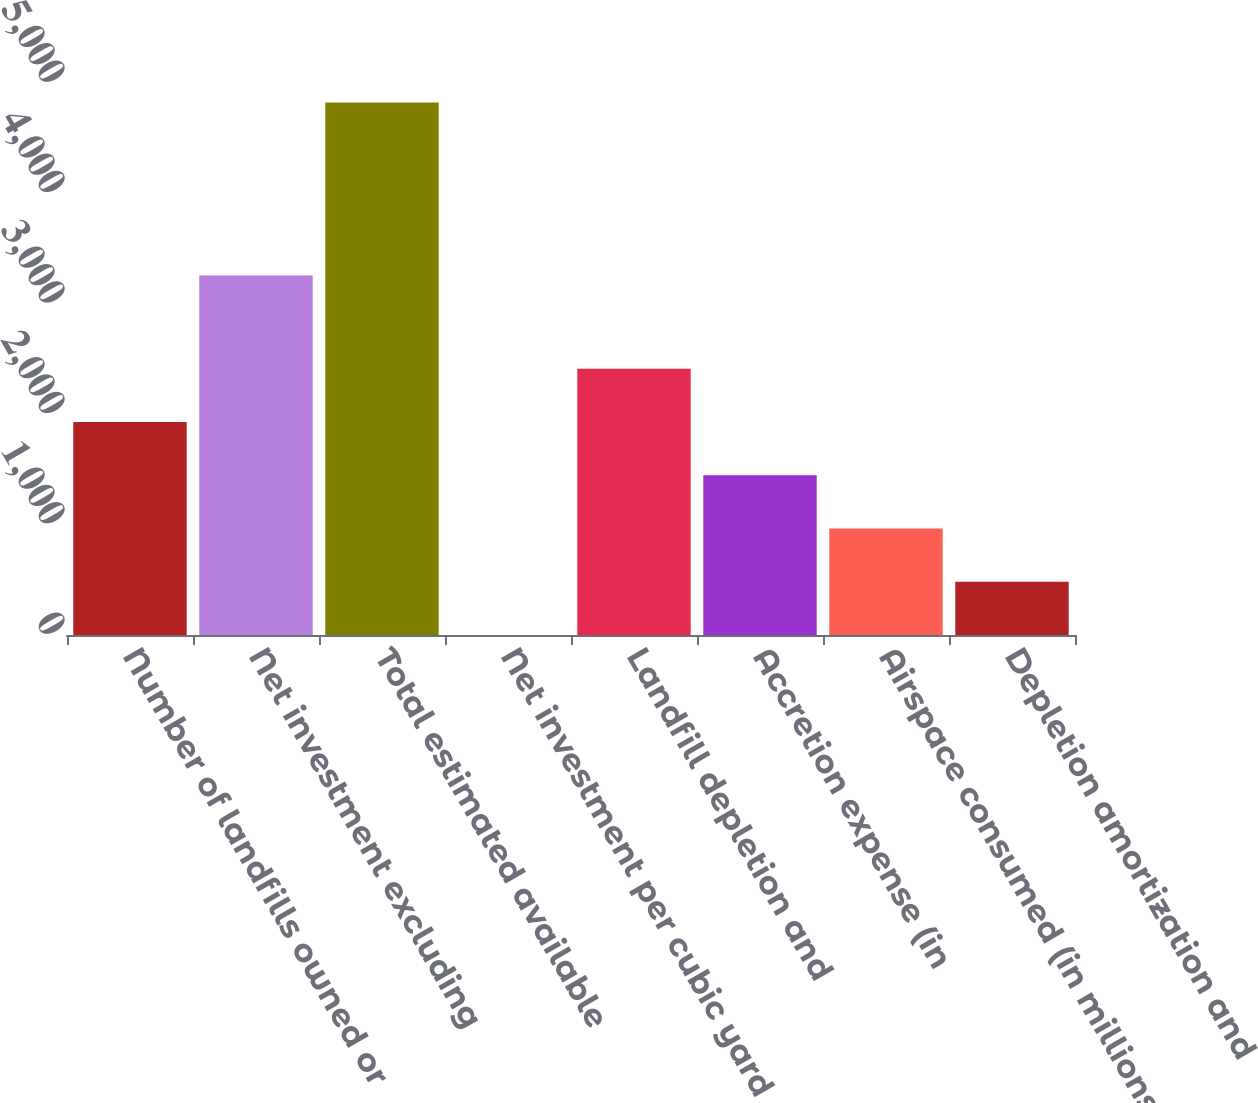Convert chart. <chart><loc_0><loc_0><loc_500><loc_500><bar_chart><fcel>Number of landfills owned or<fcel>Net investment excluding<fcel>Total estimated available<fcel>Net investment per cubic yard<fcel>Landfill depletion and<fcel>Accretion expense (in<fcel>Airspace consumed (in millions<fcel>Depletion amortization and<nl><fcel>1929.56<fcel>3256.1<fcel>4822.9<fcel>0.68<fcel>2411.78<fcel>1447.34<fcel>965.12<fcel>482.9<nl></chart> 